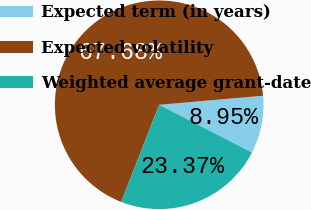<chart> <loc_0><loc_0><loc_500><loc_500><pie_chart><fcel>Expected term (in years)<fcel>Expected volatility<fcel>Weighted average grant-date<nl><fcel>8.95%<fcel>67.67%<fcel>23.37%<nl></chart> 